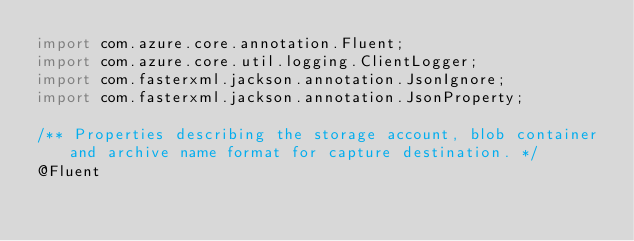<code> <loc_0><loc_0><loc_500><loc_500><_Java_>import com.azure.core.annotation.Fluent;
import com.azure.core.util.logging.ClientLogger;
import com.fasterxml.jackson.annotation.JsonIgnore;
import com.fasterxml.jackson.annotation.JsonProperty;

/** Properties describing the storage account, blob container and archive name format for capture destination. */
@Fluent</code> 